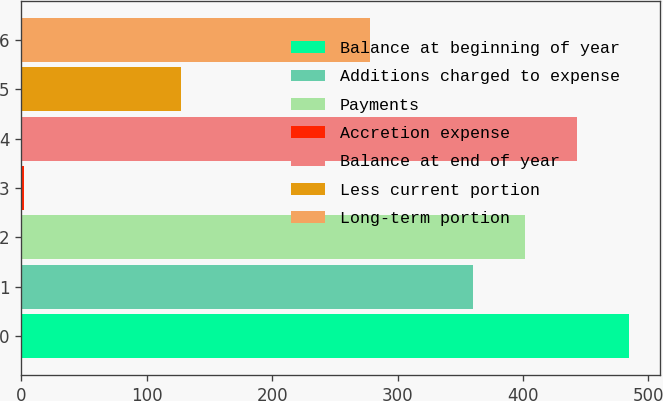<chart> <loc_0><loc_0><loc_500><loc_500><bar_chart><fcel>Balance at beginning of year<fcel>Additions charged to expense<fcel>Payments<fcel>Accretion expense<fcel>Balance at end of year<fcel>Less current portion<fcel>Long-term portion<nl><fcel>484.81<fcel>360.4<fcel>401.87<fcel>1.9<fcel>443.34<fcel>127.7<fcel>278.1<nl></chart> 